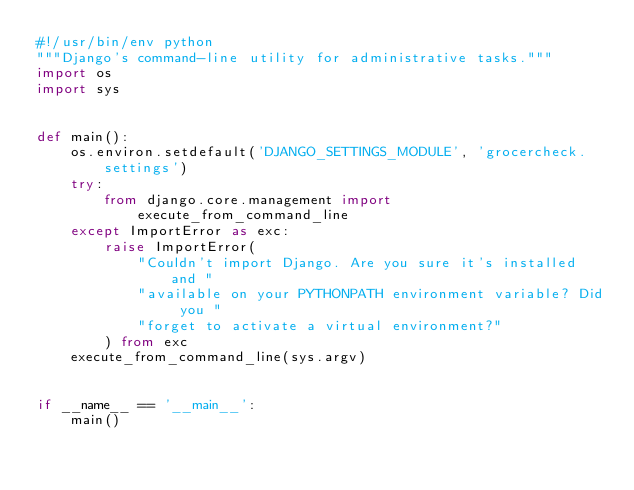<code> <loc_0><loc_0><loc_500><loc_500><_Python_>#!/usr/bin/env python
"""Django's command-line utility for administrative tasks."""
import os
import sys


def main():
    os.environ.setdefault('DJANGO_SETTINGS_MODULE', 'grocercheck.settings')
    try:
        from django.core.management import execute_from_command_line
    except ImportError as exc:
        raise ImportError(
            "Couldn't import Django. Are you sure it's installed and "
            "available on your PYTHONPATH environment variable? Did you "
            "forget to activate a virtual environment?"
        ) from exc
    execute_from_command_line(sys.argv)


if __name__ == '__main__':
    main()
</code> 